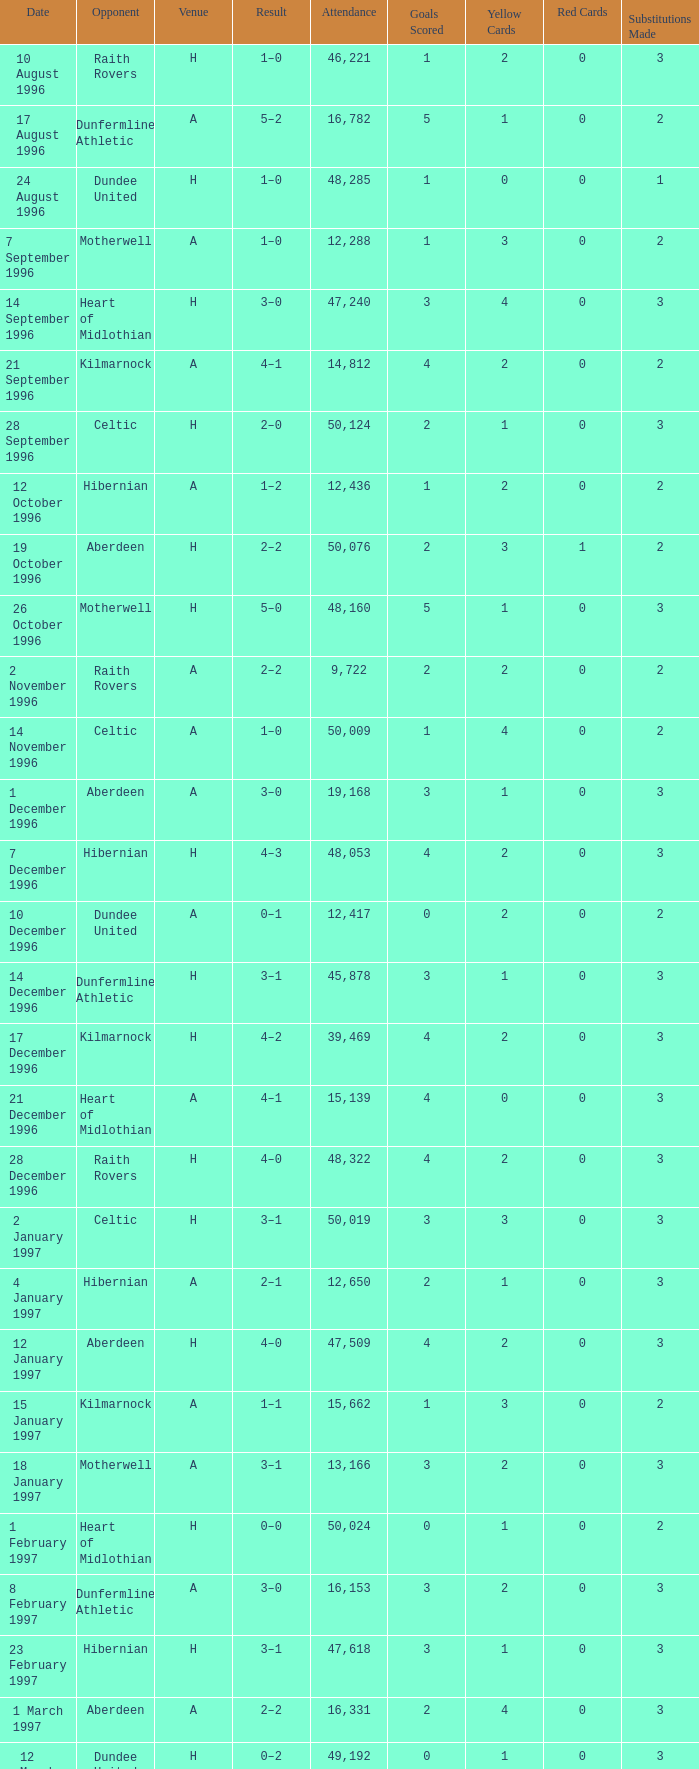When did venue A have an attendance larger than 48,053, and a result of 1–0? 14 November 1996, 16 March 1997. 